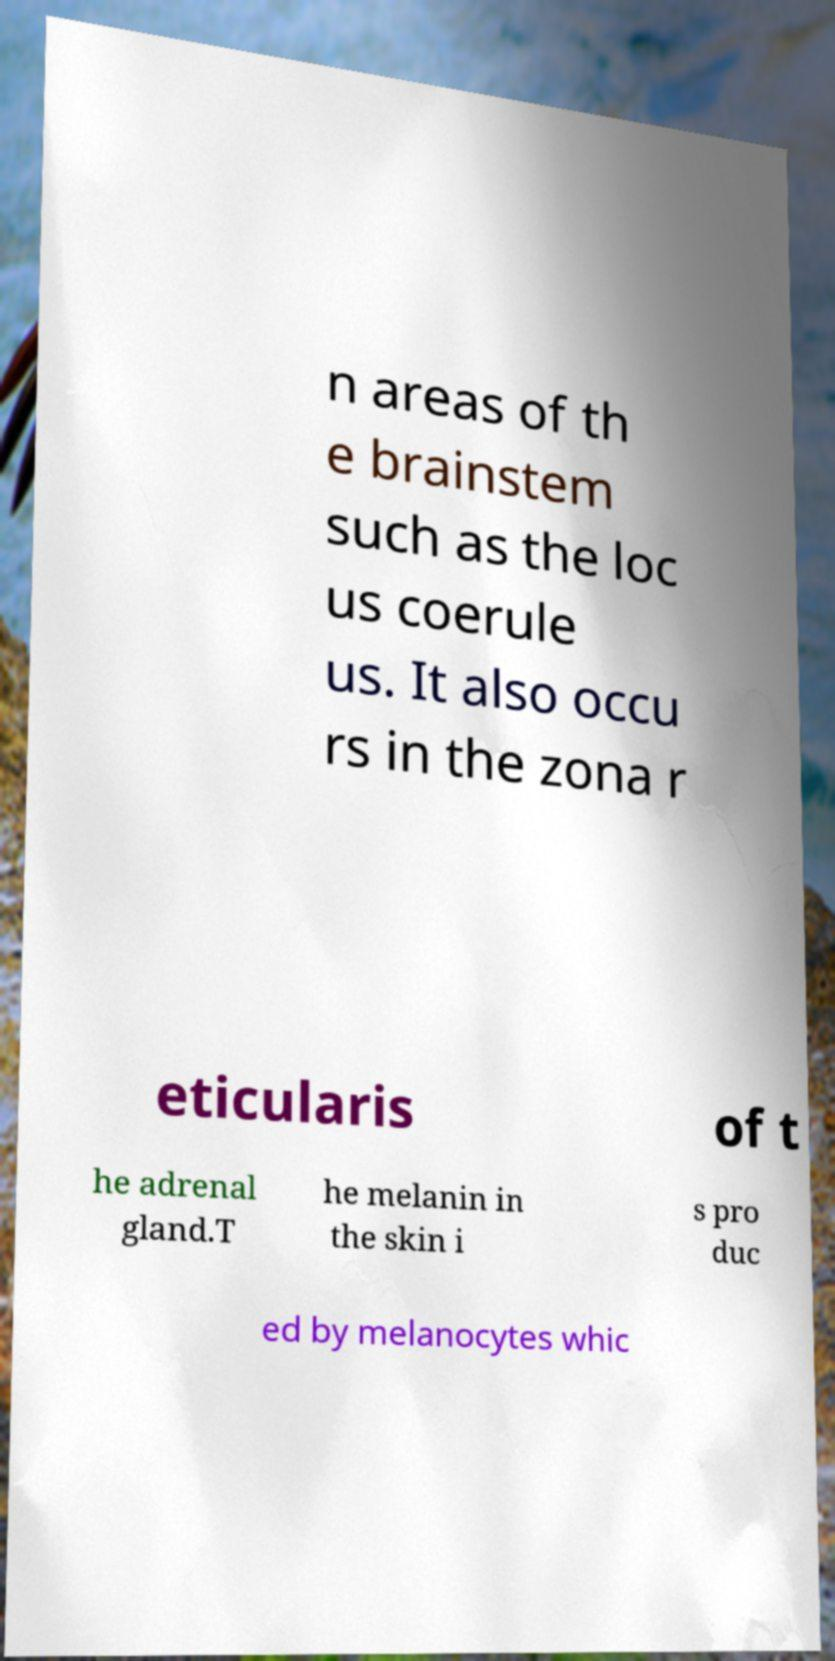What messages or text are displayed in this image? I need them in a readable, typed format. n areas of th e brainstem such as the loc us coerule us. It also occu rs in the zona r eticularis of t he adrenal gland.T he melanin in the skin i s pro duc ed by melanocytes whic 